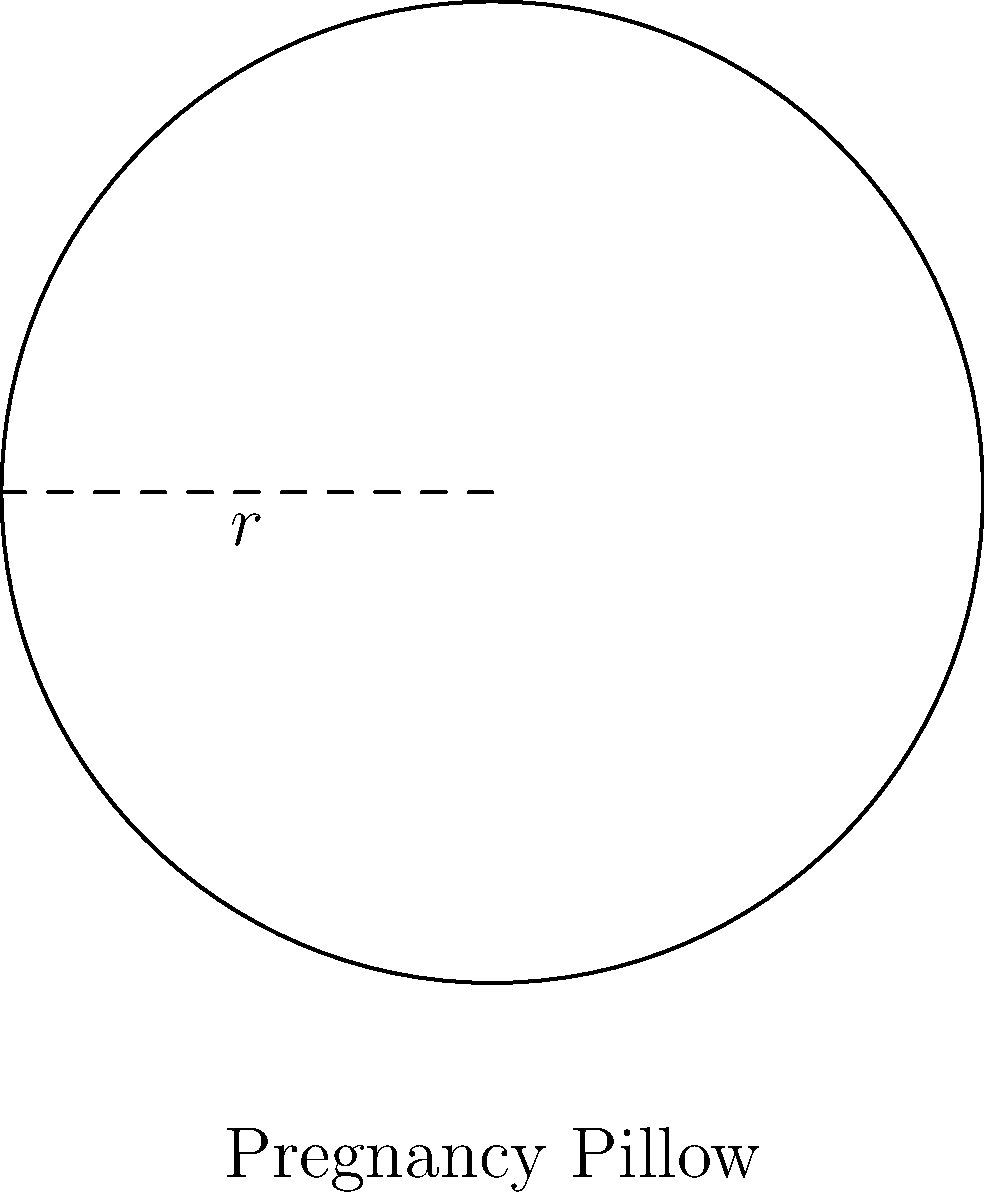You're shopping for a circular pregnancy pillow to help with your morning sickness. The pillow's diameter is 160 cm. What is the circumference of the pillow, rounded to the nearest centimeter? Let's approach this step-by-step:

1) We're given the diameter of the pillow, which is 160 cm.

2) The radius is half of the diameter:
   $r = 160 \text{ cm} \div 2 = 80 \text{ cm}$

3) The formula for the circumference of a circle is:
   $C = 2\pi r$

4) Substituting our radius value:
   $C = 2\pi (80 \text{ cm})$

5) Let's calculate:
   $C = 2 \times 3.14159... \times 80 \text{ cm}$
   $C \approx 502.65 \text{ cm}$

6) Rounding to the nearest centimeter:
   $C \approx 503 \text{ cm}$
Answer: 503 cm 